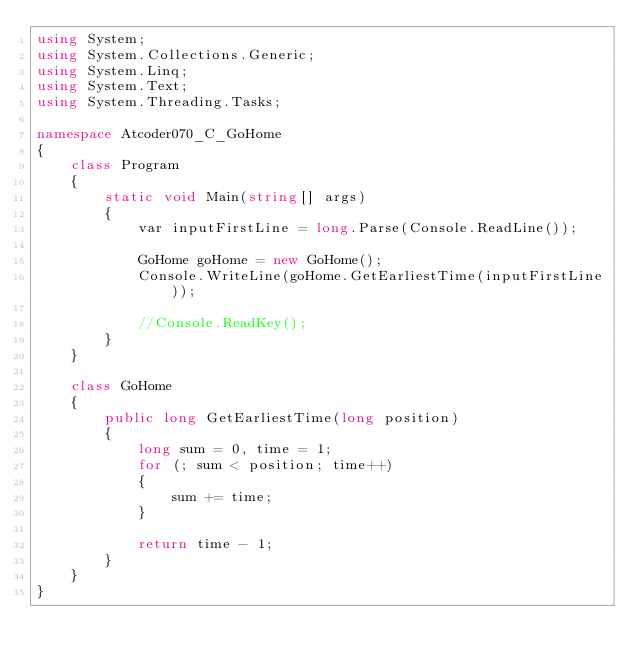Convert code to text. <code><loc_0><loc_0><loc_500><loc_500><_C#_>using System;
using System.Collections.Generic;
using System.Linq;
using System.Text;
using System.Threading.Tasks;

namespace Atcoder070_C_GoHome
{
    class Program
    {
        static void Main(string[] args)
        {
            var inputFirstLine = long.Parse(Console.ReadLine());

            GoHome goHome = new GoHome();
            Console.WriteLine(goHome.GetEarliestTime(inputFirstLine));

            //Console.ReadKey();
        }
    }

    class GoHome
    {
        public long GetEarliestTime(long position)
        {
            long sum = 0, time = 1;
            for (; sum < position; time++)
            {
                sum += time;
            }

            return time - 1;
        }
    }
}
</code> 